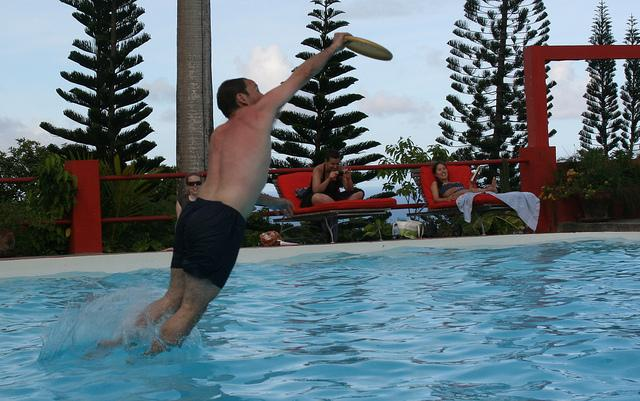Where is the man while he is swimming? pool 